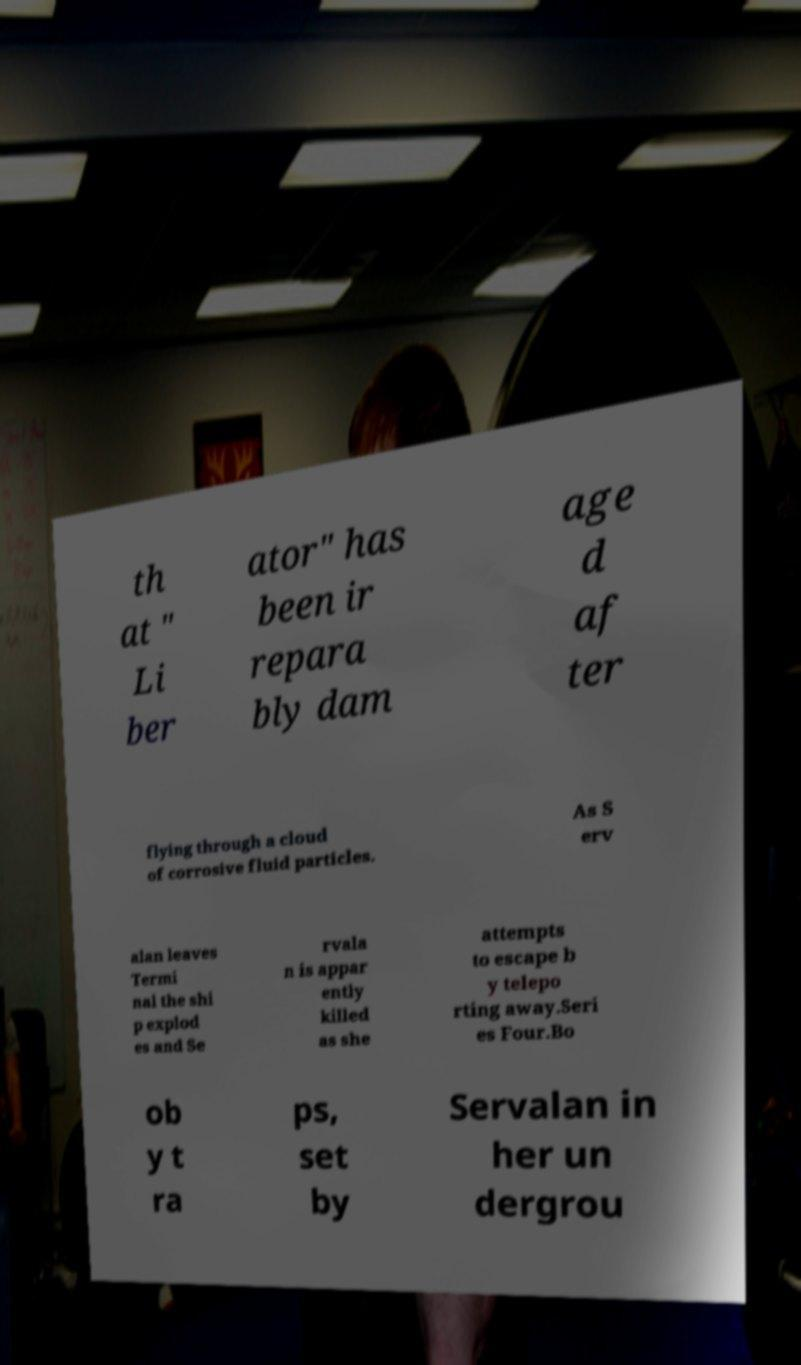Can you accurately transcribe the text from the provided image for me? th at " Li ber ator" has been ir repara bly dam age d af ter flying through a cloud of corrosive fluid particles. As S erv alan leaves Termi nal the shi p explod es and Se rvala n is appar ently killed as she attempts to escape b y telepo rting away.Seri es Four.Bo ob y t ra ps, set by Servalan in her un dergrou 